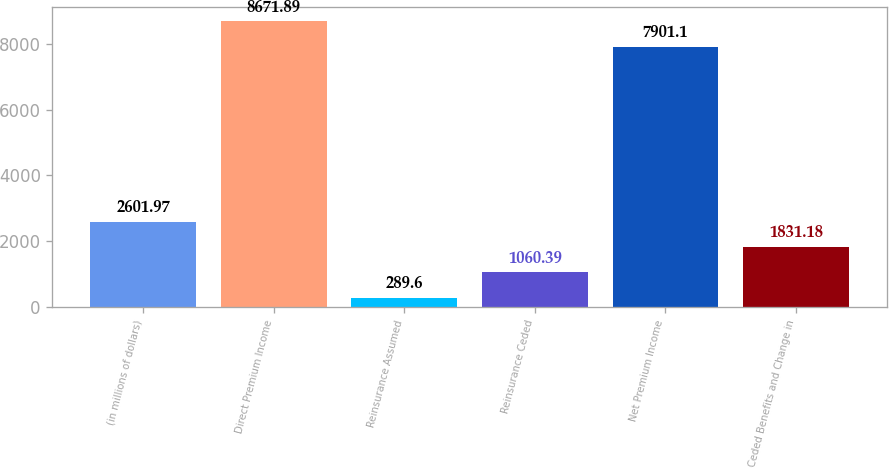Convert chart. <chart><loc_0><loc_0><loc_500><loc_500><bar_chart><fcel>(in millions of dollars)<fcel>Direct Premium Income<fcel>Reinsurance Assumed<fcel>Reinsurance Ceded<fcel>Net Premium Income<fcel>Ceded Benefits and Change in<nl><fcel>2601.97<fcel>8671.89<fcel>289.6<fcel>1060.39<fcel>7901.1<fcel>1831.18<nl></chart> 